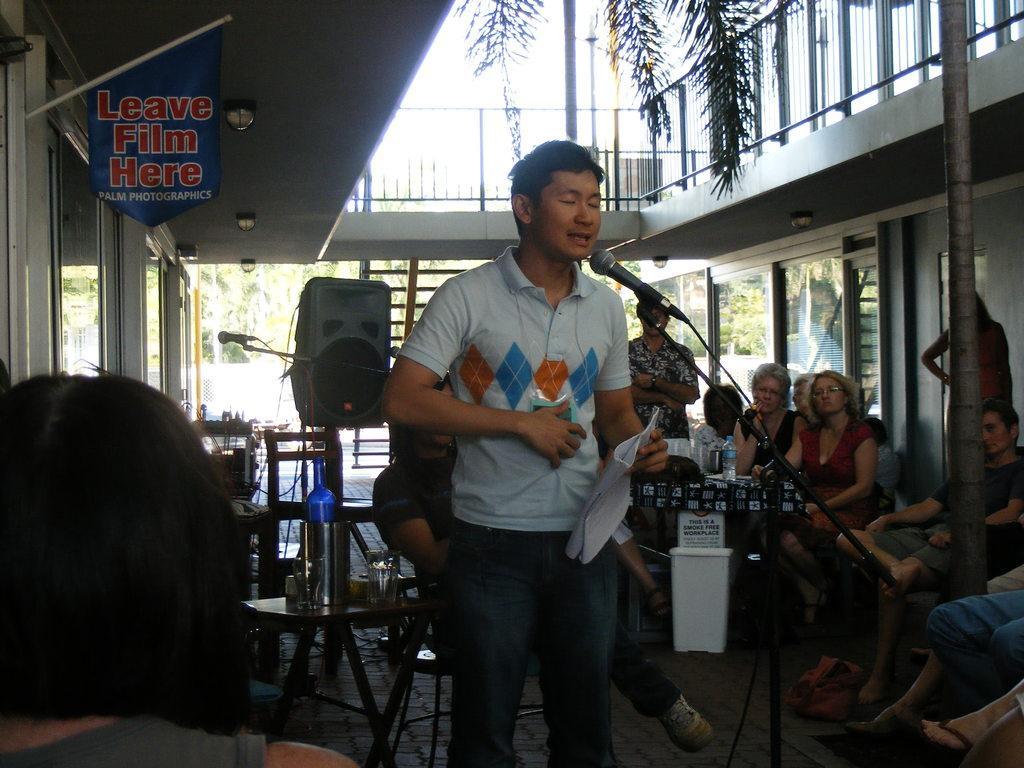Can you describe this image briefly? This picture describes about group of people, few are seated and few are standing, in the middle of the image we can see a man, he is speaking in front of the microphone and he is holding papers, in the background we can see a speaker, chairs and some other things, and also we can find few trees. 